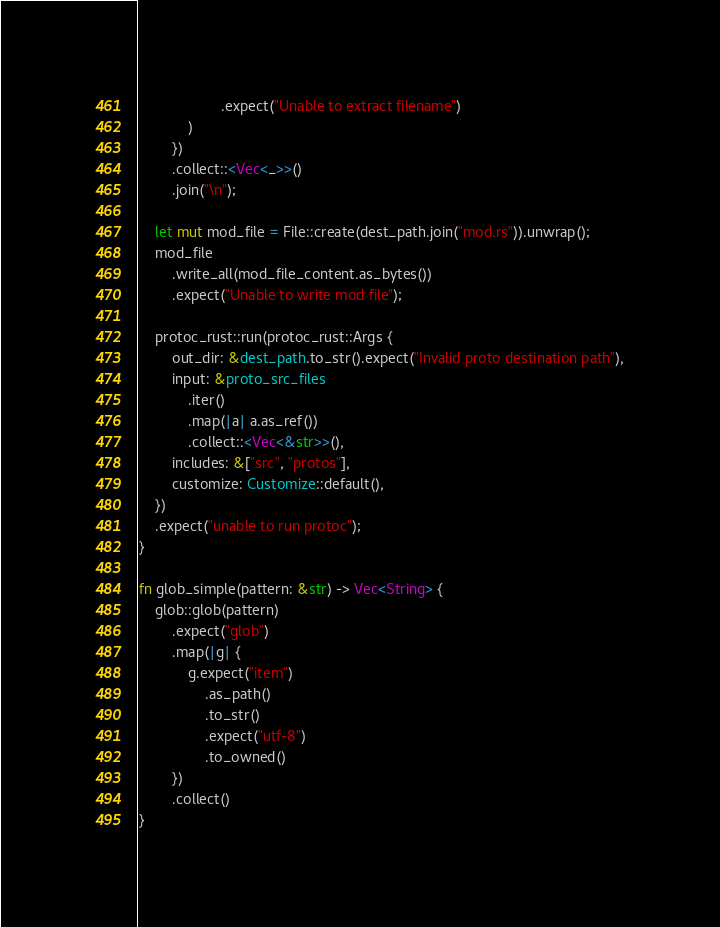<code> <loc_0><loc_0><loc_500><loc_500><_Rust_>                    .expect("Unable to extract filename")
            )
        })
        .collect::<Vec<_>>()
        .join("\n");

    let mut mod_file = File::create(dest_path.join("mod.rs")).unwrap();
    mod_file
        .write_all(mod_file_content.as_bytes())
        .expect("Unable to write mod file");

    protoc_rust::run(protoc_rust::Args {
        out_dir: &dest_path.to_str().expect("Invalid proto destination path"),
        input: &proto_src_files
            .iter()
            .map(|a| a.as_ref())
            .collect::<Vec<&str>>(),
        includes: &["src", "protos"],
        customize: Customize::default(),
    })
    .expect("unable to run protoc");
}

fn glob_simple(pattern: &str) -> Vec<String> {
    glob::glob(pattern)
        .expect("glob")
        .map(|g| {
            g.expect("item")
                .as_path()
                .to_str()
                .expect("utf-8")
                .to_owned()
        })
        .collect()
}
</code> 